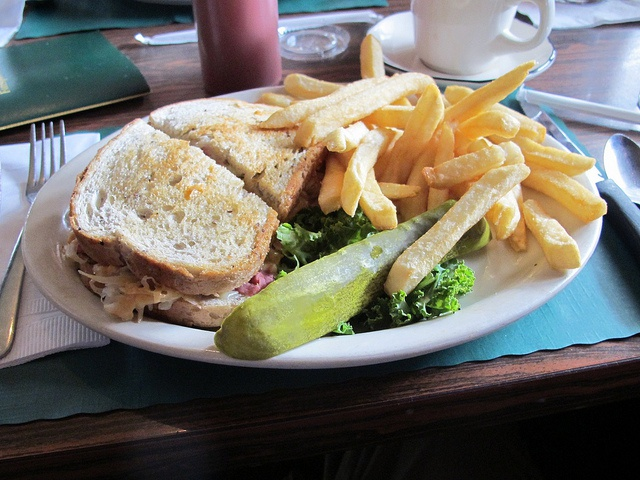Describe the objects in this image and their specific colors. I can see dining table in black, lightgray, darkgray, and gray tones, sandwich in darkgray, lightgray, and tan tones, sandwich in darkgray, lightgray, and tan tones, book in darkgray, teal, black, and gray tones, and cup in darkgray, lavender, and lightgray tones in this image. 